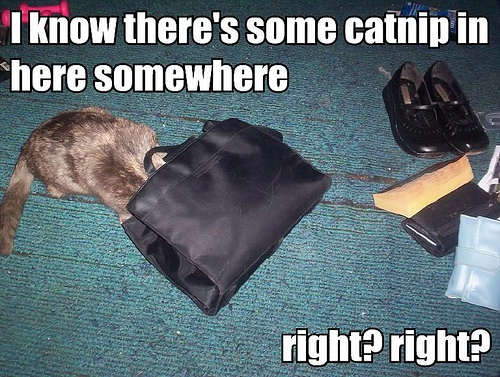Describe the objects in this image and their specific colors. I can see handbag in black and gray tones and cat in black, gray, darkgray, and tan tones in this image. 